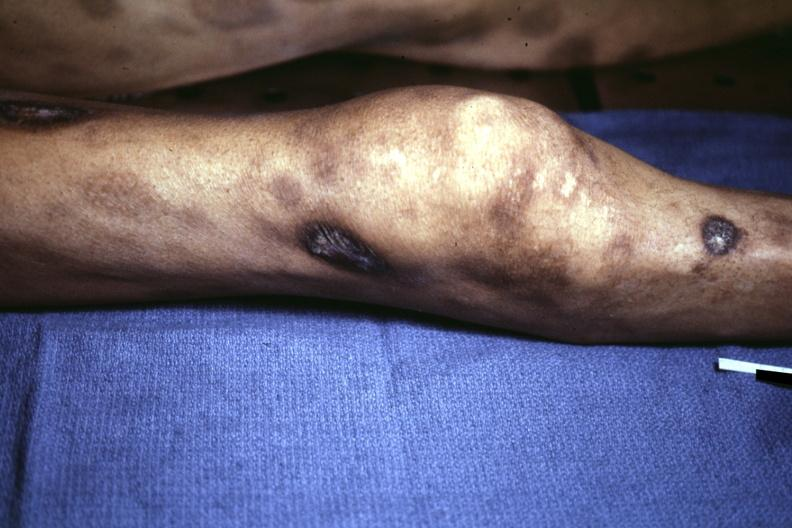where is this?
Answer the question using a single word or phrase. Skin 